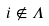<formula> <loc_0><loc_0><loc_500><loc_500>i \notin \Lambda</formula> 